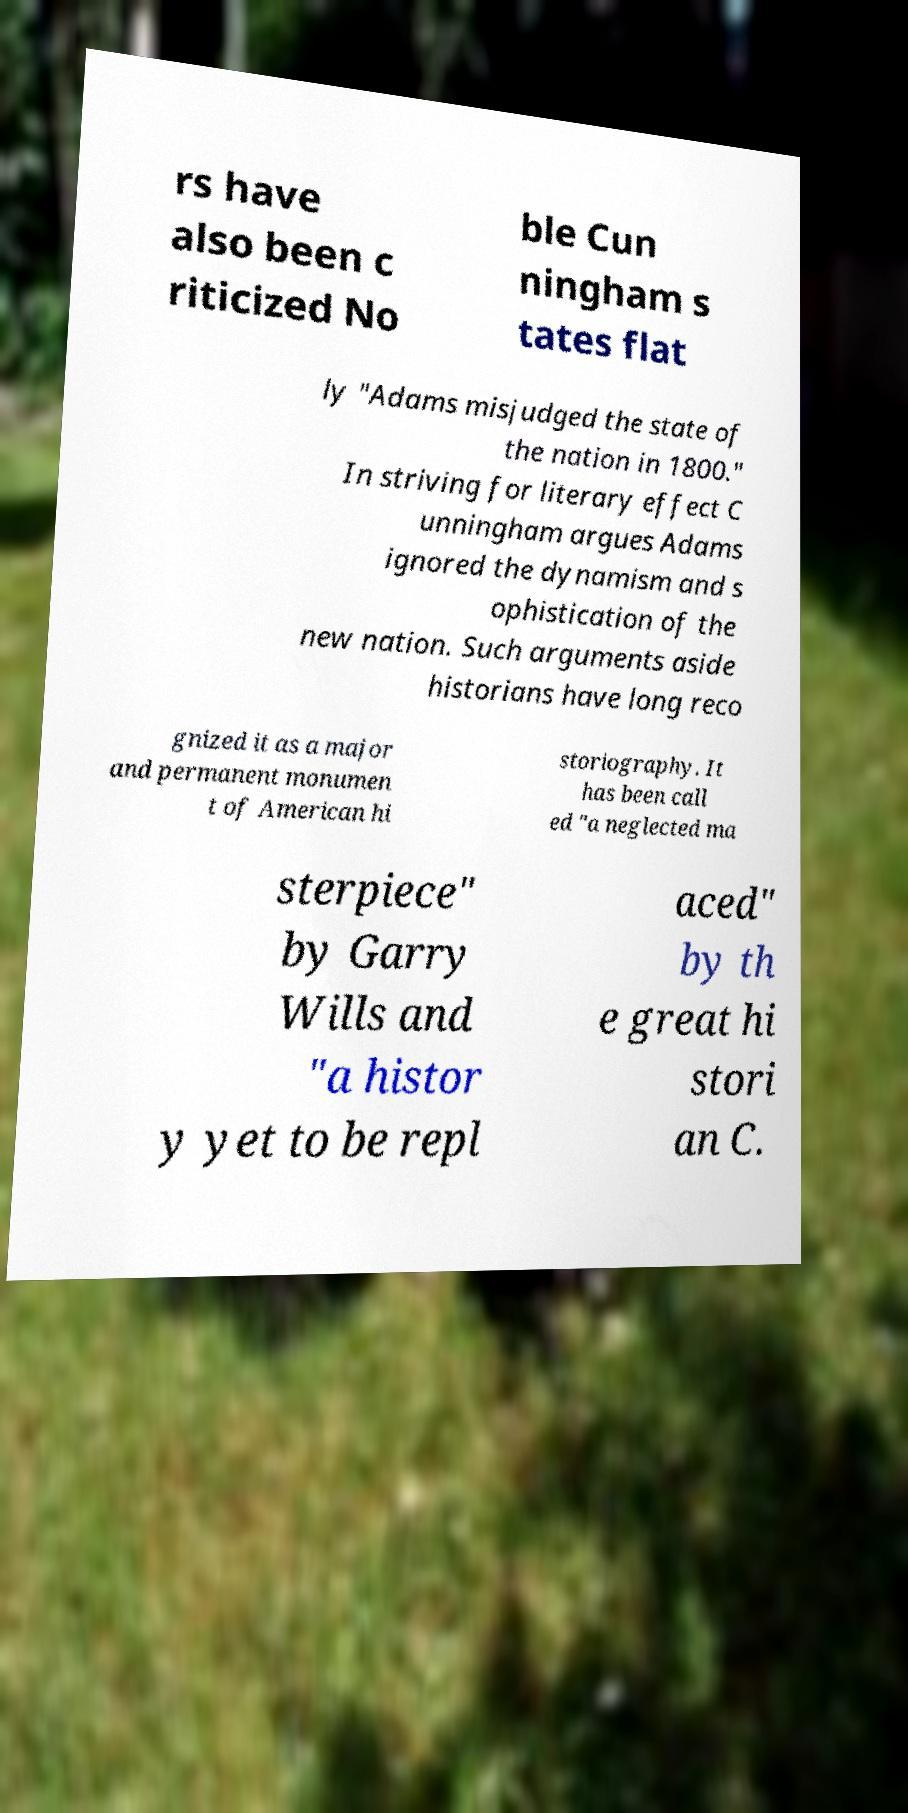Can you read and provide the text displayed in the image?This photo seems to have some interesting text. Can you extract and type it out for me? rs have also been c riticized No ble Cun ningham s tates flat ly "Adams misjudged the state of the nation in 1800." In striving for literary effect C unningham argues Adams ignored the dynamism and s ophistication of the new nation. Such arguments aside historians have long reco gnized it as a major and permanent monumen t of American hi storiography. It has been call ed "a neglected ma sterpiece" by Garry Wills and "a histor y yet to be repl aced" by th e great hi stori an C. 